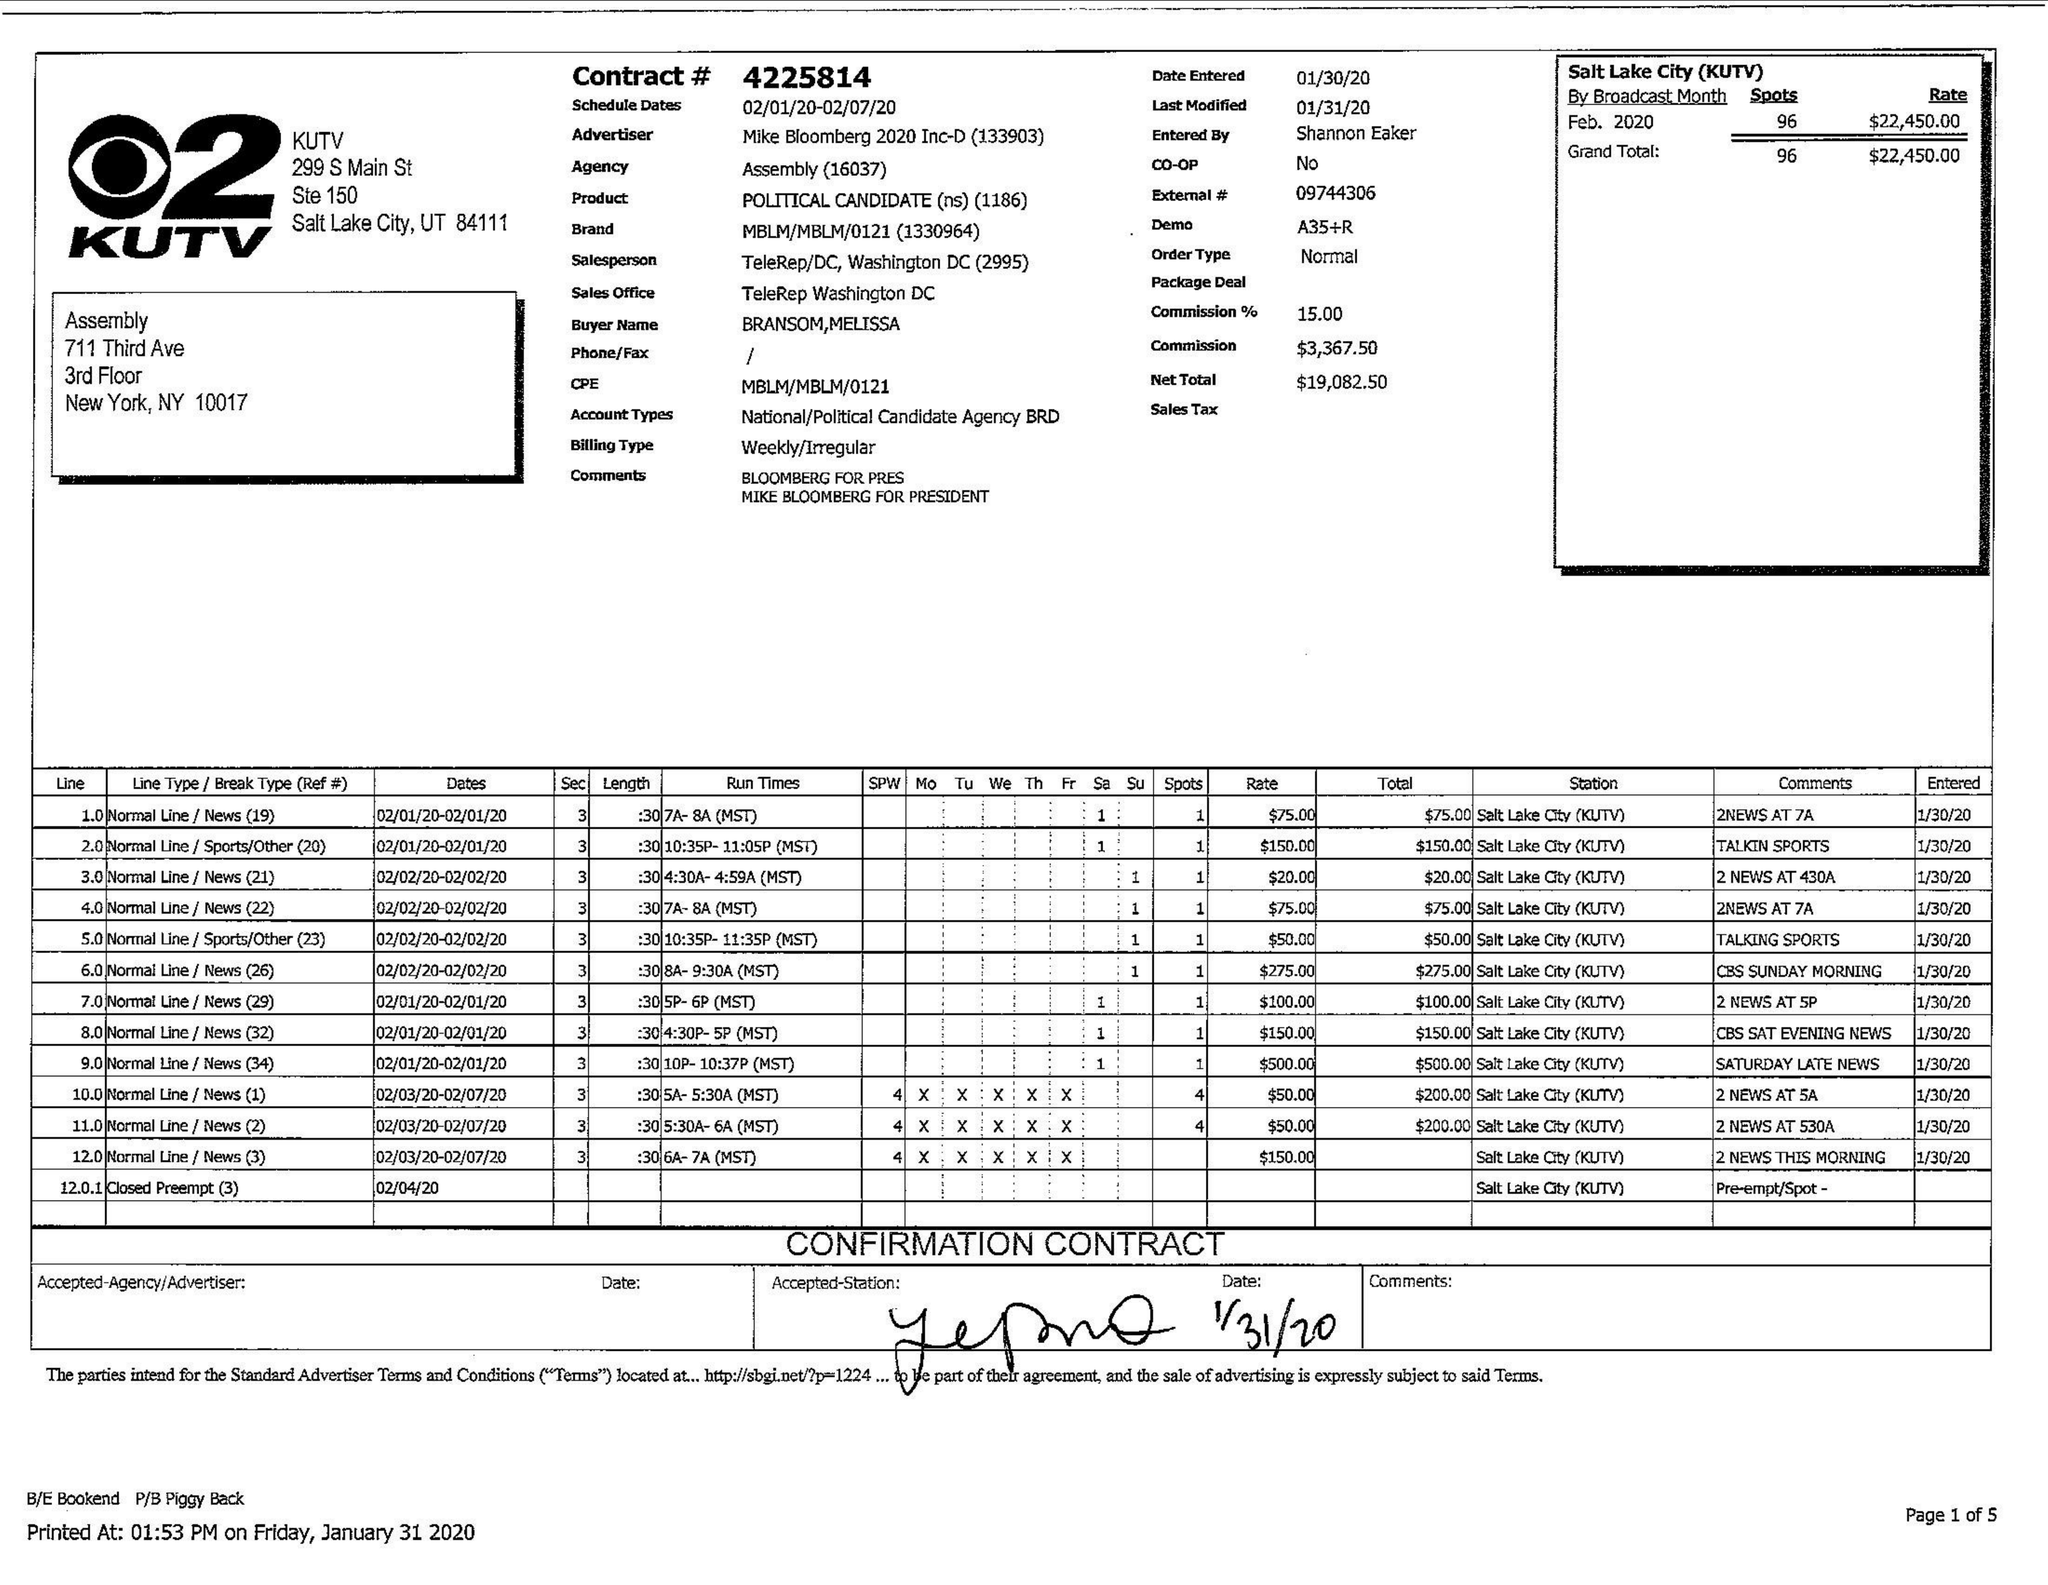What is the value for the contract_num?
Answer the question using a single word or phrase. 4225814 